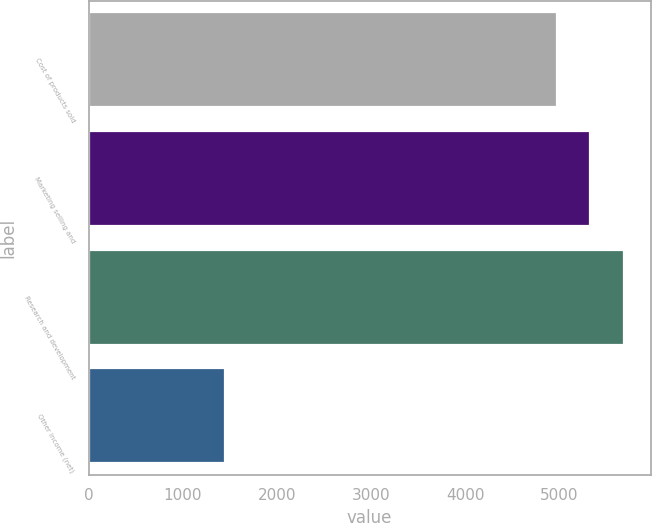Convert chart to OTSL. <chart><loc_0><loc_0><loc_500><loc_500><bar_chart><fcel>Cost of products sold<fcel>Marketing selling and<fcel>Research and development<fcel>Other income (net)<nl><fcel>4969<fcel>5325.4<fcel>5681.8<fcel>1448<nl></chart> 